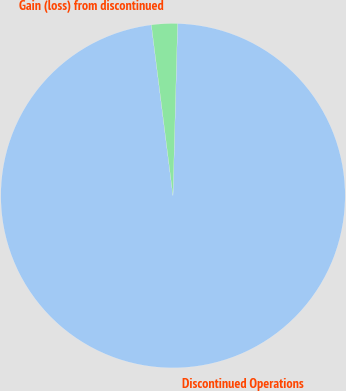<chart> <loc_0><loc_0><loc_500><loc_500><pie_chart><fcel>Discontinued Operations<fcel>Gain (loss) from discontinued<nl><fcel>97.57%<fcel>2.43%<nl></chart> 